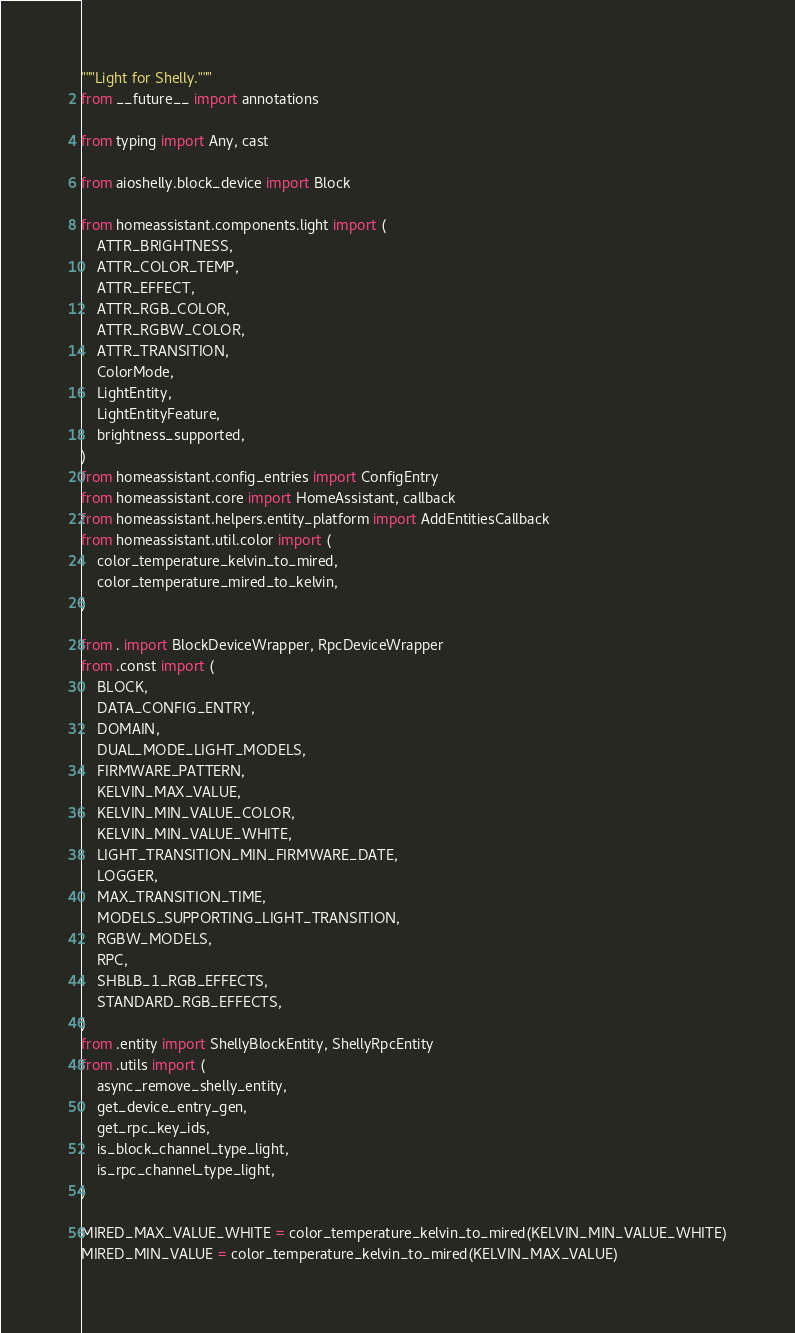Convert code to text. <code><loc_0><loc_0><loc_500><loc_500><_Python_>"""Light for Shelly."""
from __future__ import annotations

from typing import Any, cast

from aioshelly.block_device import Block

from homeassistant.components.light import (
    ATTR_BRIGHTNESS,
    ATTR_COLOR_TEMP,
    ATTR_EFFECT,
    ATTR_RGB_COLOR,
    ATTR_RGBW_COLOR,
    ATTR_TRANSITION,
    ColorMode,
    LightEntity,
    LightEntityFeature,
    brightness_supported,
)
from homeassistant.config_entries import ConfigEntry
from homeassistant.core import HomeAssistant, callback
from homeassistant.helpers.entity_platform import AddEntitiesCallback
from homeassistant.util.color import (
    color_temperature_kelvin_to_mired,
    color_temperature_mired_to_kelvin,
)

from . import BlockDeviceWrapper, RpcDeviceWrapper
from .const import (
    BLOCK,
    DATA_CONFIG_ENTRY,
    DOMAIN,
    DUAL_MODE_LIGHT_MODELS,
    FIRMWARE_PATTERN,
    KELVIN_MAX_VALUE,
    KELVIN_MIN_VALUE_COLOR,
    KELVIN_MIN_VALUE_WHITE,
    LIGHT_TRANSITION_MIN_FIRMWARE_DATE,
    LOGGER,
    MAX_TRANSITION_TIME,
    MODELS_SUPPORTING_LIGHT_TRANSITION,
    RGBW_MODELS,
    RPC,
    SHBLB_1_RGB_EFFECTS,
    STANDARD_RGB_EFFECTS,
)
from .entity import ShellyBlockEntity, ShellyRpcEntity
from .utils import (
    async_remove_shelly_entity,
    get_device_entry_gen,
    get_rpc_key_ids,
    is_block_channel_type_light,
    is_rpc_channel_type_light,
)

MIRED_MAX_VALUE_WHITE = color_temperature_kelvin_to_mired(KELVIN_MIN_VALUE_WHITE)
MIRED_MIN_VALUE = color_temperature_kelvin_to_mired(KELVIN_MAX_VALUE)</code> 